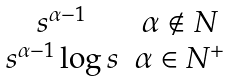Convert formula to latex. <formula><loc_0><loc_0><loc_500><loc_500>\begin{array} { c c } s ^ { \alpha - 1 } & \alpha \not \in N \\ s ^ { \alpha - 1 } \log s & \alpha \in N ^ { + } \end{array}</formula> 